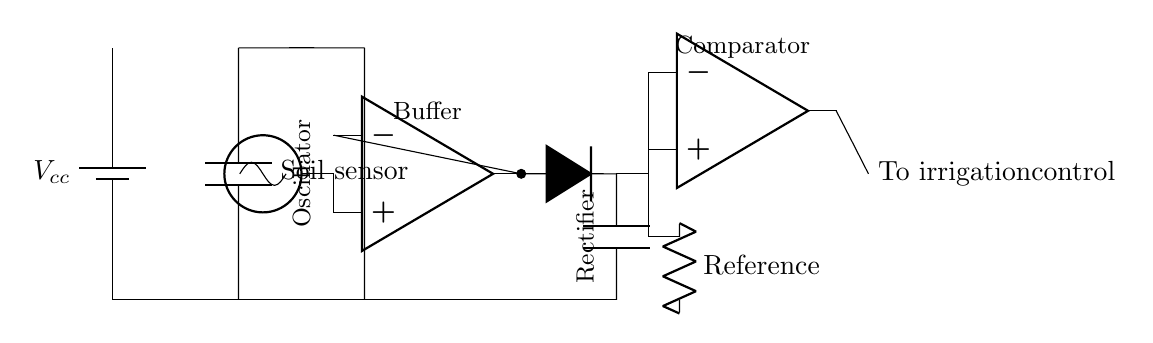What is the power supply voltage in this circuit? The circuit is powered by a battery marked as Vcc, which typically indicates a power supply voltage used for the electronic components.
Answer: Vcc What component is used as a soil moisture sensor? The circuit diagram shows a component labeled 'Soil sensor,' which indicates that it is a capacitive sensor designed to measure soil moisture.
Answer: Soil sensor What type of circuit is this primarily classified as? This circuit can be classified as an analog circuit because it processes continuous signals and comprises components like capacitors, resistors, and operational amplifiers.
Answer: Analog How many operational amplifiers are present in the circuit? By reviewing the diagram, there are two distinct operational amplifiers: one acts as a buffer and the other serves as a comparator.
Answer: Two What function does the rectifier perform in the circuit? The rectifier converts alternating current signals from the oscillator into direct current signals, helping to smooth the output for further processing by the circuit components.
Answer: Converts AC to DC What role does the comparator play in the irrigation control process? The comparator compares the output from the rectified sensor signal against a reference voltage to determine if irrigation should be activated, making it essential for controlling the irrigation system.
Answer: Control irrigation What is the main purpose of using a capacitive sensor in this circuit? Capacitive sensors are used to detect the moisture level in soil without direct contact, enhancing accuracy and reducing wear from harsh soil conditions which can affect long-term readings.
Answer: Measure soil moisture 